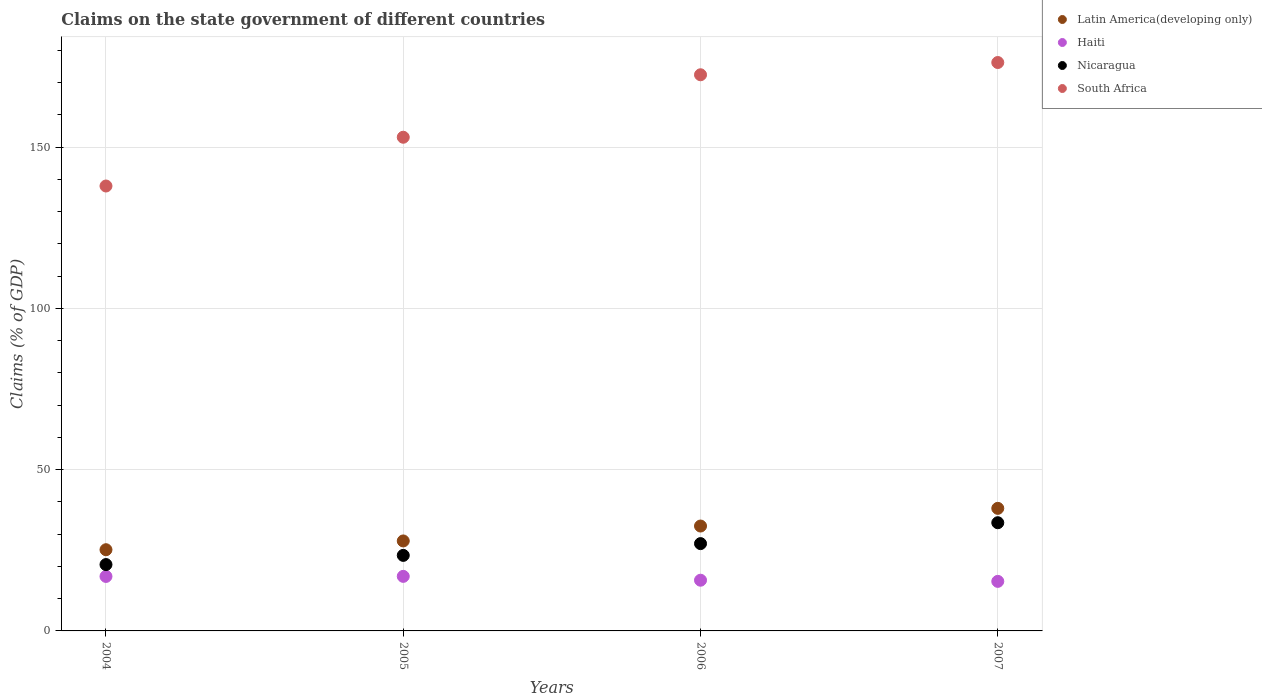Is the number of dotlines equal to the number of legend labels?
Your answer should be very brief. Yes. What is the percentage of GDP claimed on the state government in Haiti in 2007?
Your answer should be compact. 15.36. Across all years, what is the maximum percentage of GDP claimed on the state government in South Africa?
Your answer should be very brief. 176.21. Across all years, what is the minimum percentage of GDP claimed on the state government in Latin America(developing only)?
Your answer should be very brief. 25.17. In which year was the percentage of GDP claimed on the state government in Haiti minimum?
Provide a succinct answer. 2007. What is the total percentage of GDP claimed on the state government in Haiti in the graph?
Offer a very short reply. 64.89. What is the difference between the percentage of GDP claimed on the state government in Nicaragua in 2004 and that in 2007?
Make the answer very short. -12.97. What is the difference between the percentage of GDP claimed on the state government in South Africa in 2004 and the percentage of GDP claimed on the state government in Latin America(developing only) in 2005?
Make the answer very short. 110.03. What is the average percentage of GDP claimed on the state government in Haiti per year?
Provide a succinct answer. 16.22. In the year 2007, what is the difference between the percentage of GDP claimed on the state government in South Africa and percentage of GDP claimed on the state government in Nicaragua?
Offer a terse response. 142.67. What is the ratio of the percentage of GDP claimed on the state government in Latin America(developing only) in 2005 to that in 2007?
Provide a short and direct response. 0.73. Is the percentage of GDP claimed on the state government in South Africa in 2005 less than that in 2007?
Offer a terse response. Yes. What is the difference between the highest and the second highest percentage of GDP claimed on the state government in Haiti?
Ensure brevity in your answer.  0.02. What is the difference between the highest and the lowest percentage of GDP claimed on the state government in Nicaragua?
Provide a short and direct response. 12.97. In how many years, is the percentage of GDP claimed on the state government in South Africa greater than the average percentage of GDP claimed on the state government in South Africa taken over all years?
Offer a terse response. 2. Is it the case that in every year, the sum of the percentage of GDP claimed on the state government in Haiti and percentage of GDP claimed on the state government in South Africa  is greater than the percentage of GDP claimed on the state government in Latin America(developing only)?
Ensure brevity in your answer.  Yes. Does the percentage of GDP claimed on the state government in Latin America(developing only) monotonically increase over the years?
Provide a succinct answer. Yes. Is the percentage of GDP claimed on the state government in Nicaragua strictly greater than the percentage of GDP claimed on the state government in Latin America(developing only) over the years?
Your answer should be compact. No. How many years are there in the graph?
Make the answer very short. 4. How many legend labels are there?
Ensure brevity in your answer.  4. How are the legend labels stacked?
Your response must be concise. Vertical. What is the title of the graph?
Offer a terse response. Claims on the state government of different countries. What is the label or title of the X-axis?
Your answer should be compact. Years. What is the label or title of the Y-axis?
Offer a very short reply. Claims (% of GDP). What is the Claims (% of GDP) of Latin America(developing only) in 2004?
Provide a succinct answer. 25.17. What is the Claims (% of GDP) of Haiti in 2004?
Offer a very short reply. 16.89. What is the Claims (% of GDP) in Nicaragua in 2004?
Your response must be concise. 20.57. What is the Claims (% of GDP) of South Africa in 2004?
Give a very brief answer. 137.93. What is the Claims (% of GDP) in Latin America(developing only) in 2005?
Provide a short and direct response. 27.89. What is the Claims (% of GDP) of Haiti in 2005?
Provide a succinct answer. 16.91. What is the Claims (% of GDP) in Nicaragua in 2005?
Your answer should be very brief. 23.42. What is the Claims (% of GDP) of South Africa in 2005?
Your answer should be compact. 153.04. What is the Claims (% of GDP) of Latin America(developing only) in 2006?
Provide a short and direct response. 32.52. What is the Claims (% of GDP) in Haiti in 2006?
Give a very brief answer. 15.72. What is the Claims (% of GDP) of Nicaragua in 2006?
Your answer should be very brief. 27.07. What is the Claims (% of GDP) in South Africa in 2006?
Make the answer very short. 172.41. What is the Claims (% of GDP) in Latin America(developing only) in 2007?
Offer a very short reply. 38. What is the Claims (% of GDP) in Haiti in 2007?
Make the answer very short. 15.36. What is the Claims (% of GDP) in Nicaragua in 2007?
Your answer should be compact. 33.54. What is the Claims (% of GDP) in South Africa in 2007?
Your answer should be compact. 176.21. Across all years, what is the maximum Claims (% of GDP) of Latin America(developing only)?
Your response must be concise. 38. Across all years, what is the maximum Claims (% of GDP) of Haiti?
Ensure brevity in your answer.  16.91. Across all years, what is the maximum Claims (% of GDP) in Nicaragua?
Make the answer very short. 33.54. Across all years, what is the maximum Claims (% of GDP) of South Africa?
Provide a short and direct response. 176.21. Across all years, what is the minimum Claims (% of GDP) in Latin America(developing only)?
Offer a very short reply. 25.17. Across all years, what is the minimum Claims (% of GDP) in Haiti?
Provide a succinct answer. 15.36. Across all years, what is the minimum Claims (% of GDP) of Nicaragua?
Give a very brief answer. 20.57. Across all years, what is the minimum Claims (% of GDP) in South Africa?
Provide a short and direct response. 137.93. What is the total Claims (% of GDP) in Latin America(developing only) in the graph?
Your answer should be very brief. 123.58. What is the total Claims (% of GDP) of Haiti in the graph?
Give a very brief answer. 64.89. What is the total Claims (% of GDP) of Nicaragua in the graph?
Offer a terse response. 104.59. What is the total Claims (% of GDP) of South Africa in the graph?
Ensure brevity in your answer.  639.59. What is the difference between the Claims (% of GDP) in Latin America(developing only) in 2004 and that in 2005?
Provide a short and direct response. -2.72. What is the difference between the Claims (% of GDP) in Haiti in 2004 and that in 2005?
Your response must be concise. -0.02. What is the difference between the Claims (% of GDP) of Nicaragua in 2004 and that in 2005?
Make the answer very short. -2.85. What is the difference between the Claims (% of GDP) of South Africa in 2004 and that in 2005?
Offer a very short reply. -15.12. What is the difference between the Claims (% of GDP) in Latin America(developing only) in 2004 and that in 2006?
Give a very brief answer. -7.34. What is the difference between the Claims (% of GDP) of Haiti in 2004 and that in 2006?
Give a very brief answer. 1.17. What is the difference between the Claims (% of GDP) of Nicaragua in 2004 and that in 2006?
Make the answer very short. -6.5. What is the difference between the Claims (% of GDP) in South Africa in 2004 and that in 2006?
Your answer should be compact. -34.48. What is the difference between the Claims (% of GDP) of Latin America(developing only) in 2004 and that in 2007?
Give a very brief answer. -12.82. What is the difference between the Claims (% of GDP) of Haiti in 2004 and that in 2007?
Provide a short and direct response. 1.53. What is the difference between the Claims (% of GDP) in Nicaragua in 2004 and that in 2007?
Provide a short and direct response. -12.97. What is the difference between the Claims (% of GDP) of South Africa in 2004 and that in 2007?
Offer a terse response. -38.28. What is the difference between the Claims (% of GDP) of Latin America(developing only) in 2005 and that in 2006?
Offer a very short reply. -4.62. What is the difference between the Claims (% of GDP) in Haiti in 2005 and that in 2006?
Give a very brief answer. 1.19. What is the difference between the Claims (% of GDP) in Nicaragua in 2005 and that in 2006?
Ensure brevity in your answer.  -3.65. What is the difference between the Claims (% of GDP) in South Africa in 2005 and that in 2006?
Give a very brief answer. -19.37. What is the difference between the Claims (% of GDP) of Latin America(developing only) in 2005 and that in 2007?
Your answer should be compact. -10.11. What is the difference between the Claims (% of GDP) of Haiti in 2005 and that in 2007?
Provide a succinct answer. 1.55. What is the difference between the Claims (% of GDP) of Nicaragua in 2005 and that in 2007?
Your answer should be compact. -10.12. What is the difference between the Claims (% of GDP) of South Africa in 2005 and that in 2007?
Ensure brevity in your answer.  -23.17. What is the difference between the Claims (% of GDP) in Latin America(developing only) in 2006 and that in 2007?
Provide a succinct answer. -5.48. What is the difference between the Claims (% of GDP) of Haiti in 2006 and that in 2007?
Your answer should be compact. 0.36. What is the difference between the Claims (% of GDP) in Nicaragua in 2006 and that in 2007?
Your response must be concise. -6.47. What is the difference between the Claims (% of GDP) of South Africa in 2006 and that in 2007?
Give a very brief answer. -3.8. What is the difference between the Claims (% of GDP) of Latin America(developing only) in 2004 and the Claims (% of GDP) of Haiti in 2005?
Your response must be concise. 8.26. What is the difference between the Claims (% of GDP) of Latin America(developing only) in 2004 and the Claims (% of GDP) of Nicaragua in 2005?
Provide a short and direct response. 1.76. What is the difference between the Claims (% of GDP) in Latin America(developing only) in 2004 and the Claims (% of GDP) in South Africa in 2005?
Offer a terse response. -127.87. What is the difference between the Claims (% of GDP) of Haiti in 2004 and the Claims (% of GDP) of Nicaragua in 2005?
Your response must be concise. -6.52. What is the difference between the Claims (% of GDP) of Haiti in 2004 and the Claims (% of GDP) of South Africa in 2005?
Give a very brief answer. -136.15. What is the difference between the Claims (% of GDP) in Nicaragua in 2004 and the Claims (% of GDP) in South Africa in 2005?
Ensure brevity in your answer.  -132.47. What is the difference between the Claims (% of GDP) in Latin America(developing only) in 2004 and the Claims (% of GDP) in Haiti in 2006?
Keep it short and to the point. 9.45. What is the difference between the Claims (% of GDP) of Latin America(developing only) in 2004 and the Claims (% of GDP) of Nicaragua in 2006?
Your response must be concise. -1.89. What is the difference between the Claims (% of GDP) of Latin America(developing only) in 2004 and the Claims (% of GDP) of South Africa in 2006?
Make the answer very short. -147.24. What is the difference between the Claims (% of GDP) in Haiti in 2004 and the Claims (% of GDP) in Nicaragua in 2006?
Your answer should be compact. -10.17. What is the difference between the Claims (% of GDP) in Haiti in 2004 and the Claims (% of GDP) in South Africa in 2006?
Your answer should be compact. -155.51. What is the difference between the Claims (% of GDP) of Nicaragua in 2004 and the Claims (% of GDP) of South Africa in 2006?
Give a very brief answer. -151.84. What is the difference between the Claims (% of GDP) in Latin America(developing only) in 2004 and the Claims (% of GDP) in Haiti in 2007?
Ensure brevity in your answer.  9.81. What is the difference between the Claims (% of GDP) in Latin America(developing only) in 2004 and the Claims (% of GDP) in Nicaragua in 2007?
Make the answer very short. -8.37. What is the difference between the Claims (% of GDP) in Latin America(developing only) in 2004 and the Claims (% of GDP) in South Africa in 2007?
Your response must be concise. -151.04. What is the difference between the Claims (% of GDP) in Haiti in 2004 and the Claims (% of GDP) in Nicaragua in 2007?
Keep it short and to the point. -16.65. What is the difference between the Claims (% of GDP) in Haiti in 2004 and the Claims (% of GDP) in South Africa in 2007?
Keep it short and to the point. -159.31. What is the difference between the Claims (% of GDP) of Nicaragua in 2004 and the Claims (% of GDP) of South Africa in 2007?
Give a very brief answer. -155.64. What is the difference between the Claims (% of GDP) of Latin America(developing only) in 2005 and the Claims (% of GDP) of Haiti in 2006?
Provide a succinct answer. 12.17. What is the difference between the Claims (% of GDP) of Latin America(developing only) in 2005 and the Claims (% of GDP) of Nicaragua in 2006?
Offer a very short reply. 0.83. What is the difference between the Claims (% of GDP) of Latin America(developing only) in 2005 and the Claims (% of GDP) of South Africa in 2006?
Offer a very short reply. -144.52. What is the difference between the Claims (% of GDP) of Haiti in 2005 and the Claims (% of GDP) of Nicaragua in 2006?
Provide a short and direct response. -10.15. What is the difference between the Claims (% of GDP) in Haiti in 2005 and the Claims (% of GDP) in South Africa in 2006?
Your response must be concise. -155.5. What is the difference between the Claims (% of GDP) in Nicaragua in 2005 and the Claims (% of GDP) in South Africa in 2006?
Your answer should be very brief. -148.99. What is the difference between the Claims (% of GDP) in Latin America(developing only) in 2005 and the Claims (% of GDP) in Haiti in 2007?
Make the answer very short. 12.53. What is the difference between the Claims (% of GDP) in Latin America(developing only) in 2005 and the Claims (% of GDP) in Nicaragua in 2007?
Offer a very short reply. -5.65. What is the difference between the Claims (% of GDP) of Latin America(developing only) in 2005 and the Claims (% of GDP) of South Africa in 2007?
Keep it short and to the point. -148.32. What is the difference between the Claims (% of GDP) of Haiti in 2005 and the Claims (% of GDP) of Nicaragua in 2007?
Your answer should be compact. -16.63. What is the difference between the Claims (% of GDP) of Haiti in 2005 and the Claims (% of GDP) of South Africa in 2007?
Provide a short and direct response. -159.3. What is the difference between the Claims (% of GDP) in Nicaragua in 2005 and the Claims (% of GDP) in South Africa in 2007?
Your response must be concise. -152.79. What is the difference between the Claims (% of GDP) in Latin America(developing only) in 2006 and the Claims (% of GDP) in Haiti in 2007?
Provide a short and direct response. 17.15. What is the difference between the Claims (% of GDP) in Latin America(developing only) in 2006 and the Claims (% of GDP) in Nicaragua in 2007?
Offer a very short reply. -1.03. What is the difference between the Claims (% of GDP) of Latin America(developing only) in 2006 and the Claims (% of GDP) of South Africa in 2007?
Give a very brief answer. -143.69. What is the difference between the Claims (% of GDP) in Haiti in 2006 and the Claims (% of GDP) in Nicaragua in 2007?
Provide a short and direct response. -17.82. What is the difference between the Claims (% of GDP) in Haiti in 2006 and the Claims (% of GDP) in South Africa in 2007?
Ensure brevity in your answer.  -160.49. What is the difference between the Claims (% of GDP) of Nicaragua in 2006 and the Claims (% of GDP) of South Africa in 2007?
Offer a very short reply. -149.14. What is the average Claims (% of GDP) of Latin America(developing only) per year?
Your answer should be very brief. 30.9. What is the average Claims (% of GDP) of Haiti per year?
Keep it short and to the point. 16.22. What is the average Claims (% of GDP) of Nicaragua per year?
Offer a terse response. 26.15. What is the average Claims (% of GDP) in South Africa per year?
Your response must be concise. 159.9. In the year 2004, what is the difference between the Claims (% of GDP) of Latin America(developing only) and Claims (% of GDP) of Haiti?
Your answer should be compact. 8.28. In the year 2004, what is the difference between the Claims (% of GDP) in Latin America(developing only) and Claims (% of GDP) in Nicaragua?
Offer a very short reply. 4.6. In the year 2004, what is the difference between the Claims (% of GDP) of Latin America(developing only) and Claims (% of GDP) of South Africa?
Offer a terse response. -112.75. In the year 2004, what is the difference between the Claims (% of GDP) in Haiti and Claims (% of GDP) in Nicaragua?
Ensure brevity in your answer.  -3.68. In the year 2004, what is the difference between the Claims (% of GDP) in Haiti and Claims (% of GDP) in South Africa?
Your answer should be very brief. -121.03. In the year 2004, what is the difference between the Claims (% of GDP) in Nicaragua and Claims (% of GDP) in South Africa?
Keep it short and to the point. -117.36. In the year 2005, what is the difference between the Claims (% of GDP) in Latin America(developing only) and Claims (% of GDP) in Haiti?
Provide a short and direct response. 10.98. In the year 2005, what is the difference between the Claims (% of GDP) in Latin America(developing only) and Claims (% of GDP) in Nicaragua?
Offer a very short reply. 4.48. In the year 2005, what is the difference between the Claims (% of GDP) in Latin America(developing only) and Claims (% of GDP) in South Africa?
Make the answer very short. -125.15. In the year 2005, what is the difference between the Claims (% of GDP) in Haiti and Claims (% of GDP) in Nicaragua?
Offer a very short reply. -6.5. In the year 2005, what is the difference between the Claims (% of GDP) of Haiti and Claims (% of GDP) of South Africa?
Keep it short and to the point. -136.13. In the year 2005, what is the difference between the Claims (% of GDP) in Nicaragua and Claims (% of GDP) in South Africa?
Offer a very short reply. -129.63. In the year 2006, what is the difference between the Claims (% of GDP) of Latin America(developing only) and Claims (% of GDP) of Haiti?
Keep it short and to the point. 16.8. In the year 2006, what is the difference between the Claims (% of GDP) of Latin America(developing only) and Claims (% of GDP) of Nicaragua?
Offer a terse response. 5.45. In the year 2006, what is the difference between the Claims (% of GDP) of Latin America(developing only) and Claims (% of GDP) of South Africa?
Provide a succinct answer. -139.89. In the year 2006, what is the difference between the Claims (% of GDP) in Haiti and Claims (% of GDP) in Nicaragua?
Offer a very short reply. -11.35. In the year 2006, what is the difference between the Claims (% of GDP) of Haiti and Claims (% of GDP) of South Africa?
Make the answer very short. -156.69. In the year 2006, what is the difference between the Claims (% of GDP) in Nicaragua and Claims (% of GDP) in South Africa?
Give a very brief answer. -145.34. In the year 2007, what is the difference between the Claims (% of GDP) of Latin America(developing only) and Claims (% of GDP) of Haiti?
Your answer should be very brief. 22.64. In the year 2007, what is the difference between the Claims (% of GDP) of Latin America(developing only) and Claims (% of GDP) of Nicaragua?
Provide a succinct answer. 4.46. In the year 2007, what is the difference between the Claims (% of GDP) in Latin America(developing only) and Claims (% of GDP) in South Africa?
Your answer should be compact. -138.21. In the year 2007, what is the difference between the Claims (% of GDP) of Haiti and Claims (% of GDP) of Nicaragua?
Ensure brevity in your answer.  -18.18. In the year 2007, what is the difference between the Claims (% of GDP) of Haiti and Claims (% of GDP) of South Africa?
Give a very brief answer. -160.85. In the year 2007, what is the difference between the Claims (% of GDP) in Nicaragua and Claims (% of GDP) in South Africa?
Offer a terse response. -142.67. What is the ratio of the Claims (% of GDP) in Latin America(developing only) in 2004 to that in 2005?
Make the answer very short. 0.9. What is the ratio of the Claims (% of GDP) of Haiti in 2004 to that in 2005?
Make the answer very short. 1. What is the ratio of the Claims (% of GDP) in Nicaragua in 2004 to that in 2005?
Offer a terse response. 0.88. What is the ratio of the Claims (% of GDP) in South Africa in 2004 to that in 2005?
Your answer should be very brief. 0.9. What is the ratio of the Claims (% of GDP) in Latin America(developing only) in 2004 to that in 2006?
Your answer should be very brief. 0.77. What is the ratio of the Claims (% of GDP) in Haiti in 2004 to that in 2006?
Offer a very short reply. 1.07. What is the ratio of the Claims (% of GDP) of Nicaragua in 2004 to that in 2006?
Offer a very short reply. 0.76. What is the ratio of the Claims (% of GDP) in South Africa in 2004 to that in 2006?
Make the answer very short. 0.8. What is the ratio of the Claims (% of GDP) of Latin America(developing only) in 2004 to that in 2007?
Ensure brevity in your answer.  0.66. What is the ratio of the Claims (% of GDP) in Haiti in 2004 to that in 2007?
Your response must be concise. 1.1. What is the ratio of the Claims (% of GDP) in Nicaragua in 2004 to that in 2007?
Your answer should be very brief. 0.61. What is the ratio of the Claims (% of GDP) in South Africa in 2004 to that in 2007?
Provide a succinct answer. 0.78. What is the ratio of the Claims (% of GDP) of Latin America(developing only) in 2005 to that in 2006?
Your response must be concise. 0.86. What is the ratio of the Claims (% of GDP) in Haiti in 2005 to that in 2006?
Give a very brief answer. 1.08. What is the ratio of the Claims (% of GDP) of Nicaragua in 2005 to that in 2006?
Provide a short and direct response. 0.87. What is the ratio of the Claims (% of GDP) in South Africa in 2005 to that in 2006?
Offer a terse response. 0.89. What is the ratio of the Claims (% of GDP) in Latin America(developing only) in 2005 to that in 2007?
Ensure brevity in your answer.  0.73. What is the ratio of the Claims (% of GDP) in Haiti in 2005 to that in 2007?
Provide a short and direct response. 1.1. What is the ratio of the Claims (% of GDP) in Nicaragua in 2005 to that in 2007?
Your answer should be very brief. 0.7. What is the ratio of the Claims (% of GDP) in South Africa in 2005 to that in 2007?
Keep it short and to the point. 0.87. What is the ratio of the Claims (% of GDP) of Latin America(developing only) in 2006 to that in 2007?
Offer a terse response. 0.86. What is the ratio of the Claims (% of GDP) of Haiti in 2006 to that in 2007?
Offer a very short reply. 1.02. What is the ratio of the Claims (% of GDP) of Nicaragua in 2006 to that in 2007?
Provide a short and direct response. 0.81. What is the ratio of the Claims (% of GDP) of South Africa in 2006 to that in 2007?
Provide a short and direct response. 0.98. What is the difference between the highest and the second highest Claims (% of GDP) in Latin America(developing only)?
Make the answer very short. 5.48. What is the difference between the highest and the second highest Claims (% of GDP) in Haiti?
Offer a terse response. 0.02. What is the difference between the highest and the second highest Claims (% of GDP) in Nicaragua?
Your response must be concise. 6.47. What is the difference between the highest and the second highest Claims (% of GDP) in South Africa?
Offer a very short reply. 3.8. What is the difference between the highest and the lowest Claims (% of GDP) of Latin America(developing only)?
Ensure brevity in your answer.  12.82. What is the difference between the highest and the lowest Claims (% of GDP) of Haiti?
Offer a terse response. 1.55. What is the difference between the highest and the lowest Claims (% of GDP) of Nicaragua?
Your response must be concise. 12.97. What is the difference between the highest and the lowest Claims (% of GDP) in South Africa?
Offer a very short reply. 38.28. 